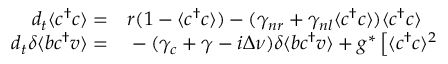<formula> <loc_0><loc_0><loc_500><loc_500>\begin{array} { r l } { d _ { t } \langle c ^ { \dagger } c \rangle = } & r ( 1 - \langle c ^ { \dagger } c \rangle ) - ( \gamma _ { n r } + \gamma _ { n l } \langle c ^ { \dagger } c \rangle ) \langle c ^ { \dagger } c \rangle } \\ { d _ { t } \delta \langle b c ^ { \dagger } v \rangle = } & - ( \gamma _ { c } + \gamma - i \Delta \nu ) \delta \langle b c ^ { \dagger } v \rangle + g ^ { * } \left [ \langle c ^ { \dagger } c \rangle ^ { 2 } } \end{array}</formula> 